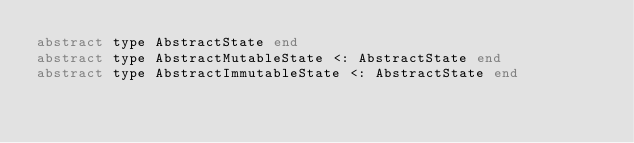Convert code to text. <code><loc_0><loc_0><loc_500><loc_500><_Julia_>abstract type AbstractState end
abstract type AbstractMutableState <: AbstractState end
abstract type AbstractImmutableState <: AbstractState end
</code> 